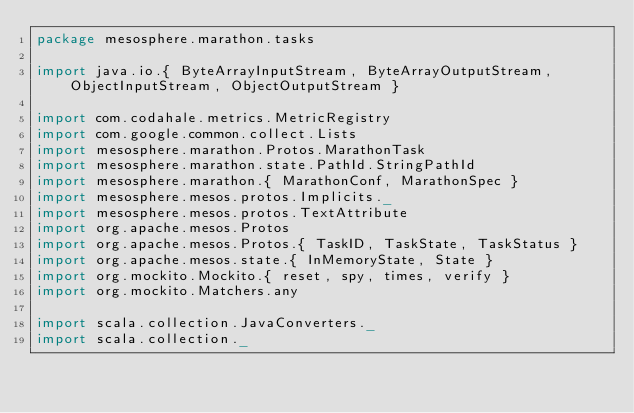Convert code to text. <code><loc_0><loc_0><loc_500><loc_500><_Scala_>package mesosphere.marathon.tasks

import java.io.{ ByteArrayInputStream, ByteArrayOutputStream, ObjectInputStream, ObjectOutputStream }

import com.codahale.metrics.MetricRegistry
import com.google.common.collect.Lists
import mesosphere.marathon.Protos.MarathonTask
import mesosphere.marathon.state.PathId.StringPathId
import mesosphere.marathon.{ MarathonConf, MarathonSpec }
import mesosphere.mesos.protos.Implicits._
import mesosphere.mesos.protos.TextAttribute
import org.apache.mesos.Protos
import org.apache.mesos.Protos.{ TaskID, TaskState, TaskStatus }
import org.apache.mesos.state.{ InMemoryState, State }
import org.mockito.Mockito.{ reset, spy, times, verify }
import org.mockito.Matchers.any

import scala.collection.JavaConverters._
import scala.collection._</code> 